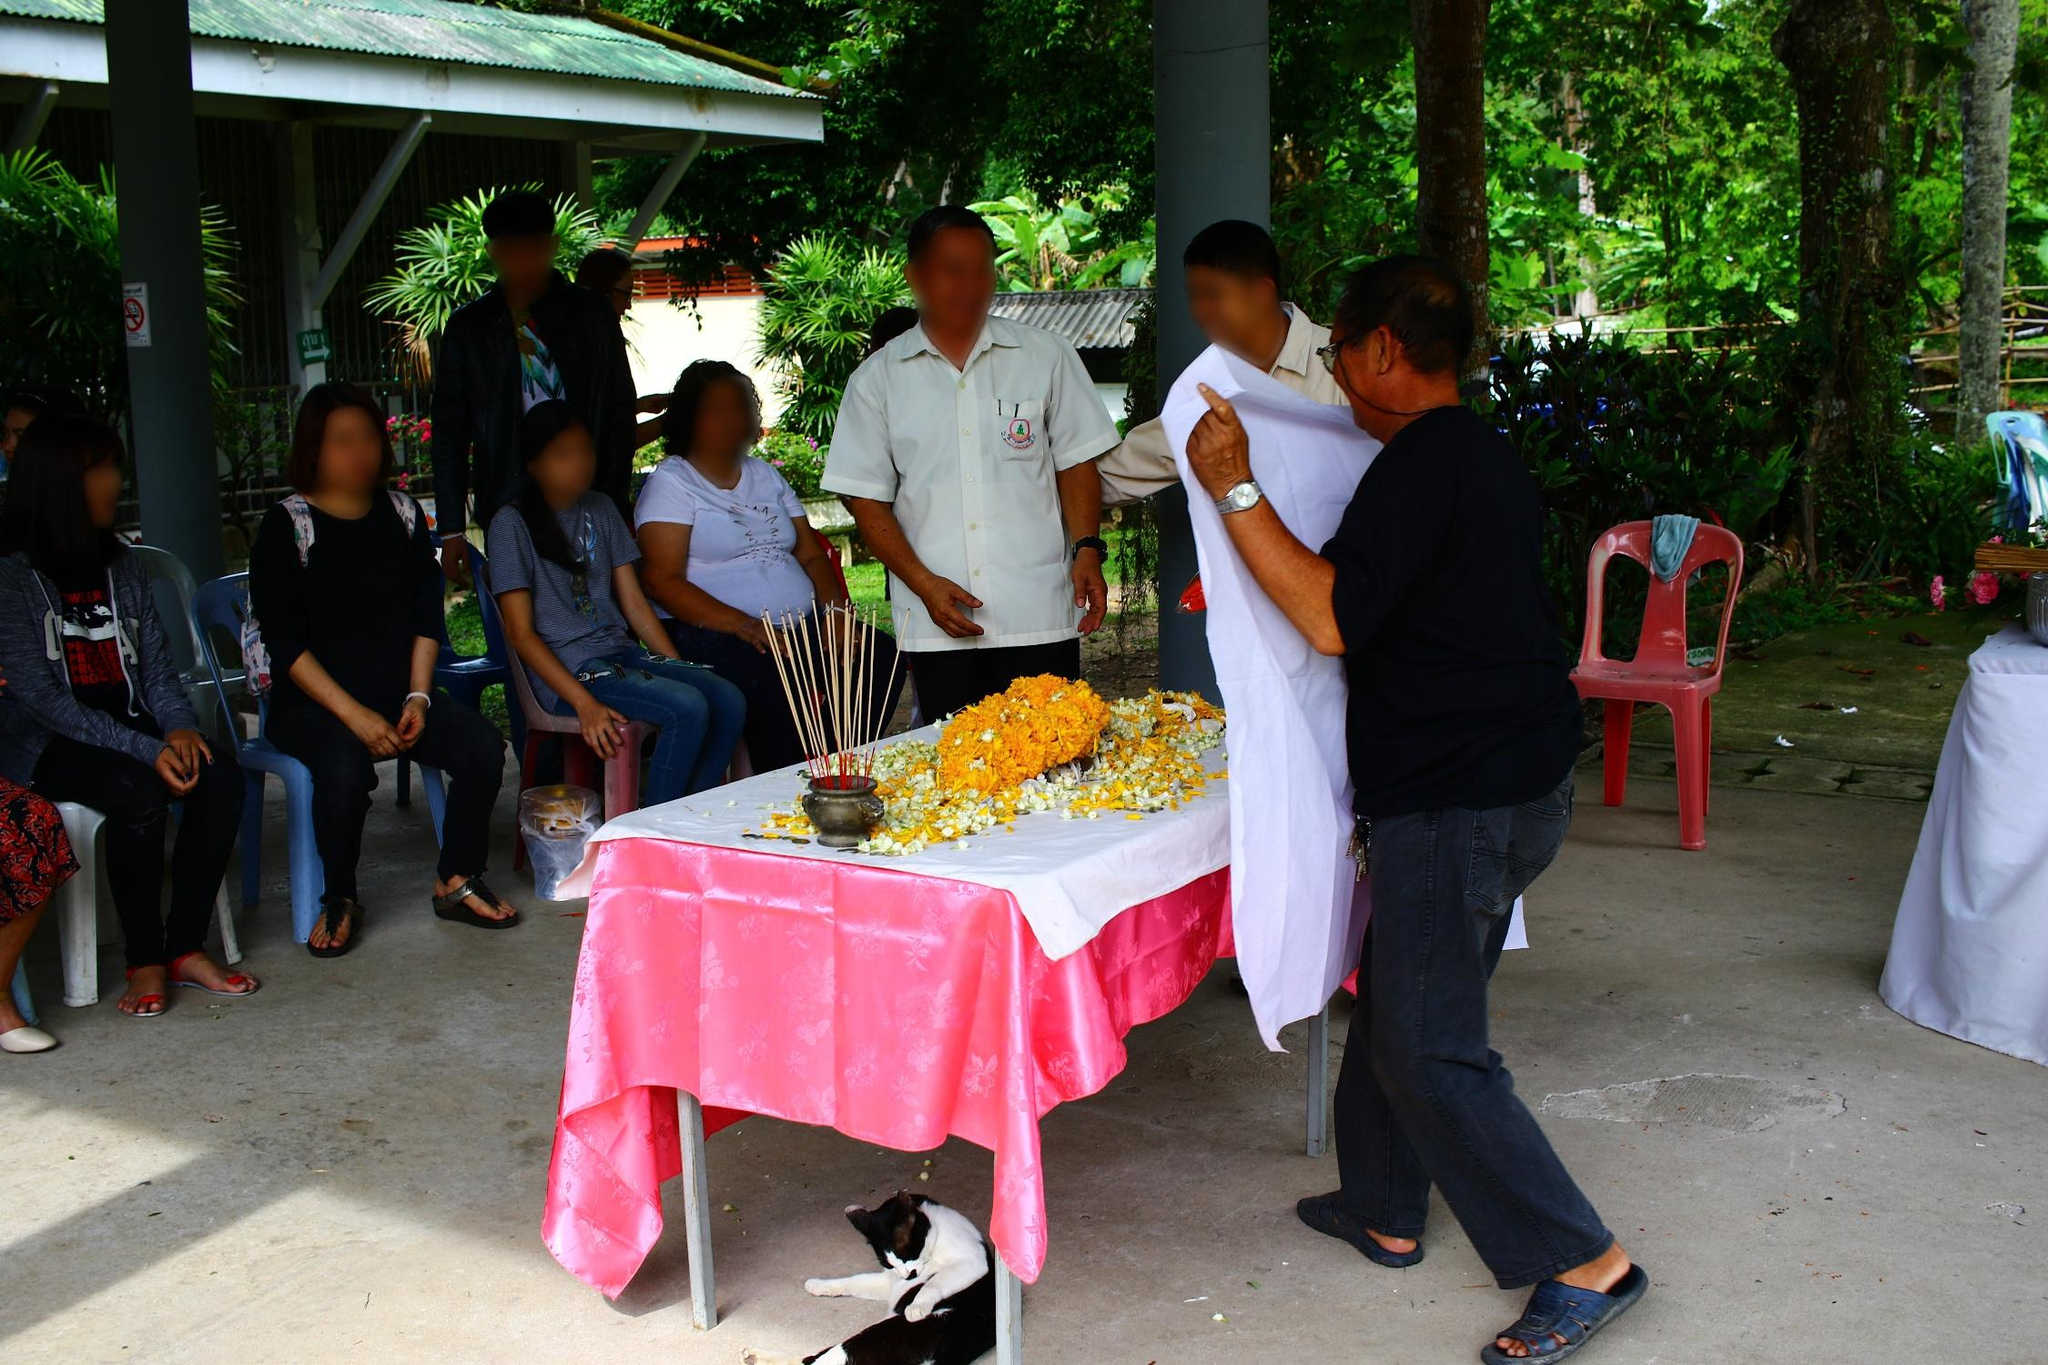Analyze the image in a comprehensive and detailed manner.
 The image captures a lively scene of a gathering in a tropical setting. A group of people are clustered around a table draped in a pink tablecloth. The table is adorned with a large flower arrangement in vibrant hues of orange and yellow, and a bowl of incense sticks adds to the ambiance. 

A man in a white shirt and a woman in a blue shirt are standing at the table, engaged in conversation, while others are seated nearby, contributing to the convivial atmosphere. A black and white cat, seemingly undisturbed by the activity, is comfortably lying on the ground next to the table.

The backdrop of palm trees and a wooden structure suggests a tropical location, enhancing the overall relaxed and casual mood of the gathering. The image is rich in color and detail, offering a glimpse into a moment of social interaction and camaraderie. 

As for the landmark information "sa_10254", I'm sorry but I couldn't find any relevant information about it from my search results. It might be helpful to provide more context or check the information for accuracy. 